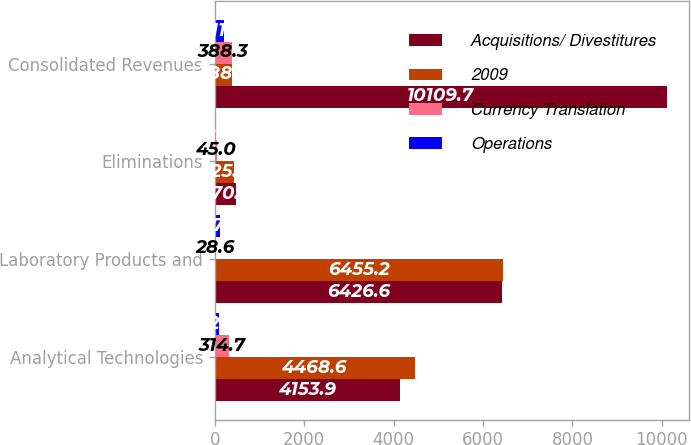Convert chart. <chart><loc_0><loc_0><loc_500><loc_500><stacked_bar_chart><ecel><fcel>Analytical Technologies<fcel>Laboratory Products and<fcel>Eliminations<fcel>Consolidated Revenues<nl><fcel>Acquisitions/ Divestitures<fcel>4153.9<fcel>6426.6<fcel>470.8<fcel>10109.7<nl><fcel>2009<fcel>4468.6<fcel>6455.2<fcel>425.8<fcel>388.3<nl><fcel>Currency Translation<fcel>314.7<fcel>28.6<fcel>45<fcel>388.3<nl><fcel>Operations<fcel>92.2<fcel>127.5<fcel>8.6<fcel>211.1<nl></chart> 